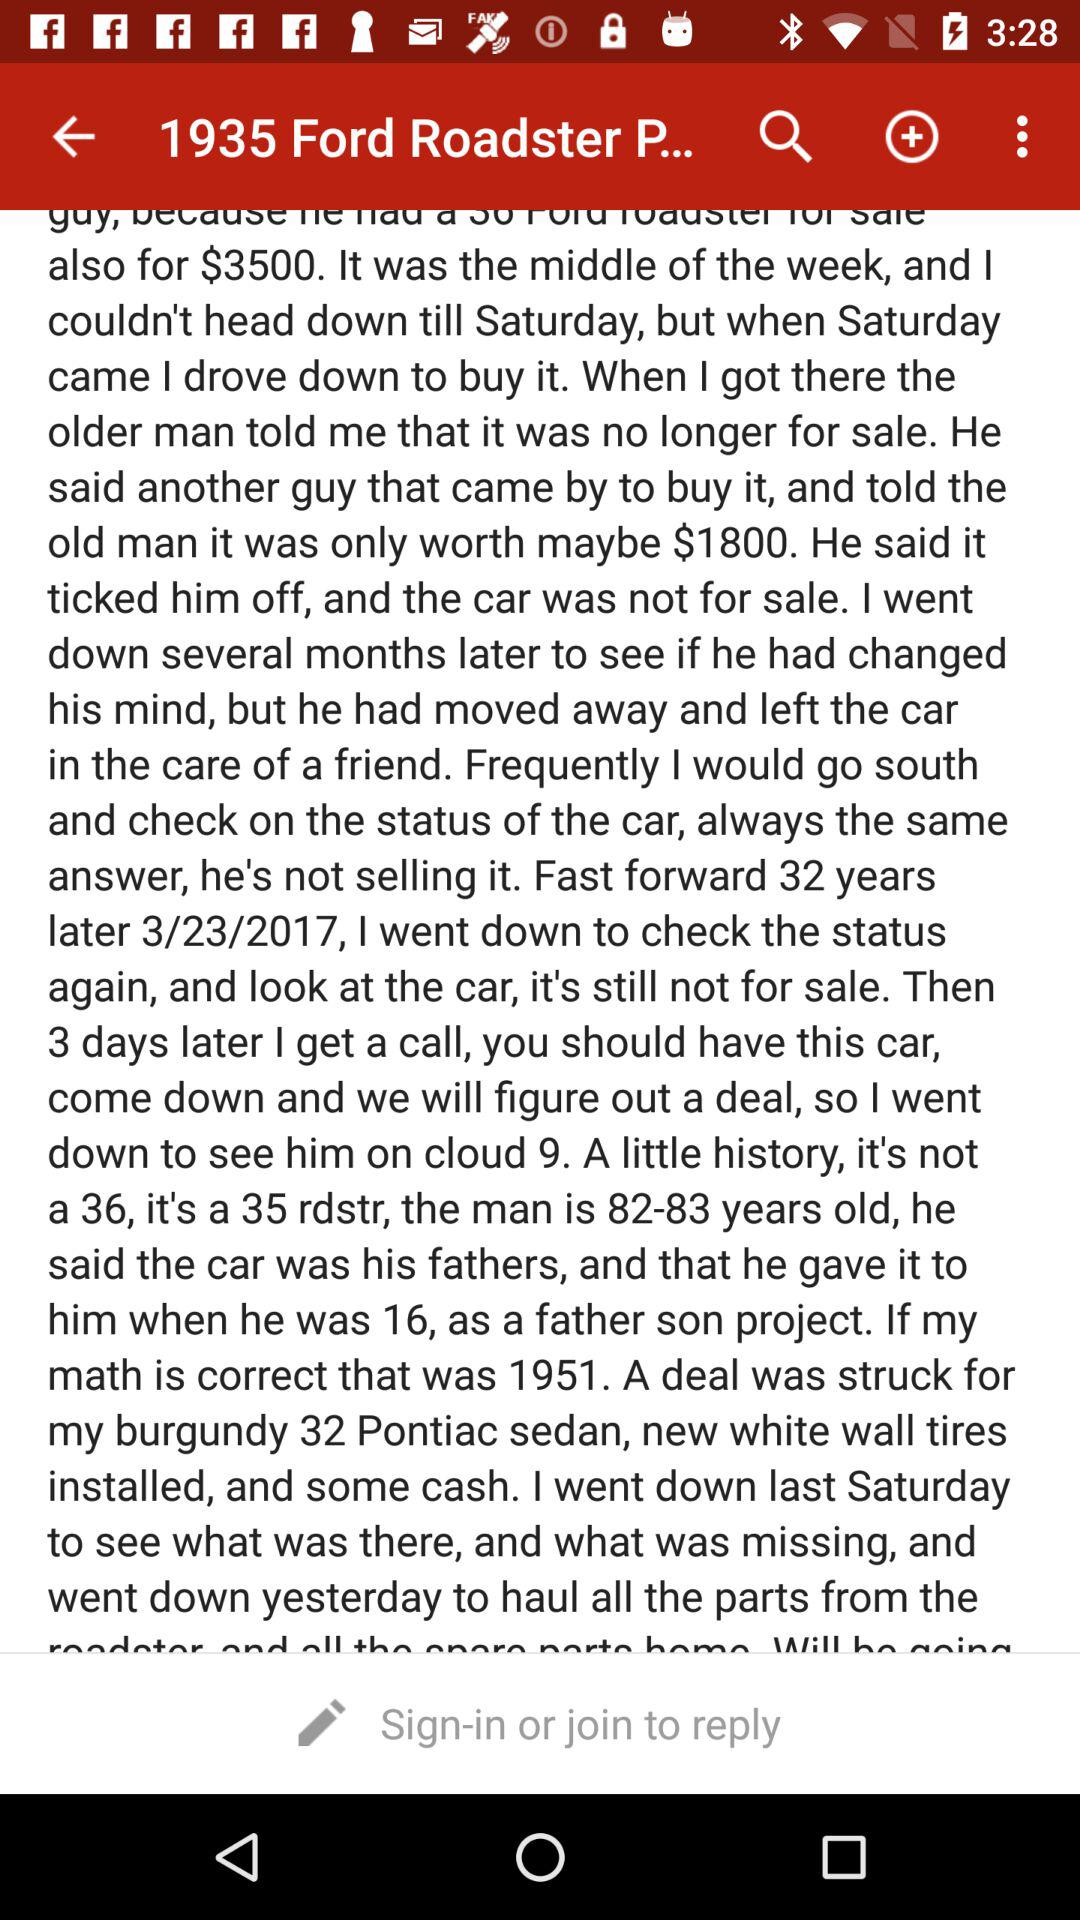How much more did the author pay for the car than the original asking price?
Answer the question using a single word or phrase. 1700 